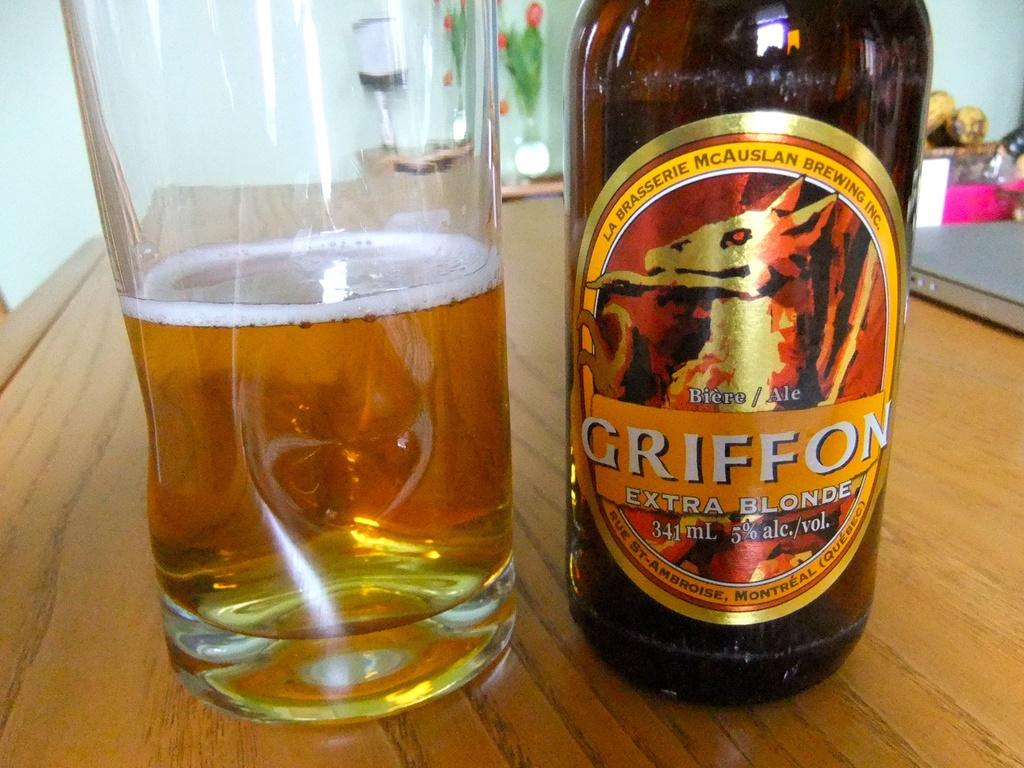<image>
Share a concise interpretation of the image provided. Half empty glass of GRIFFON extra blonde 5% ale and its bottle on the counter. 